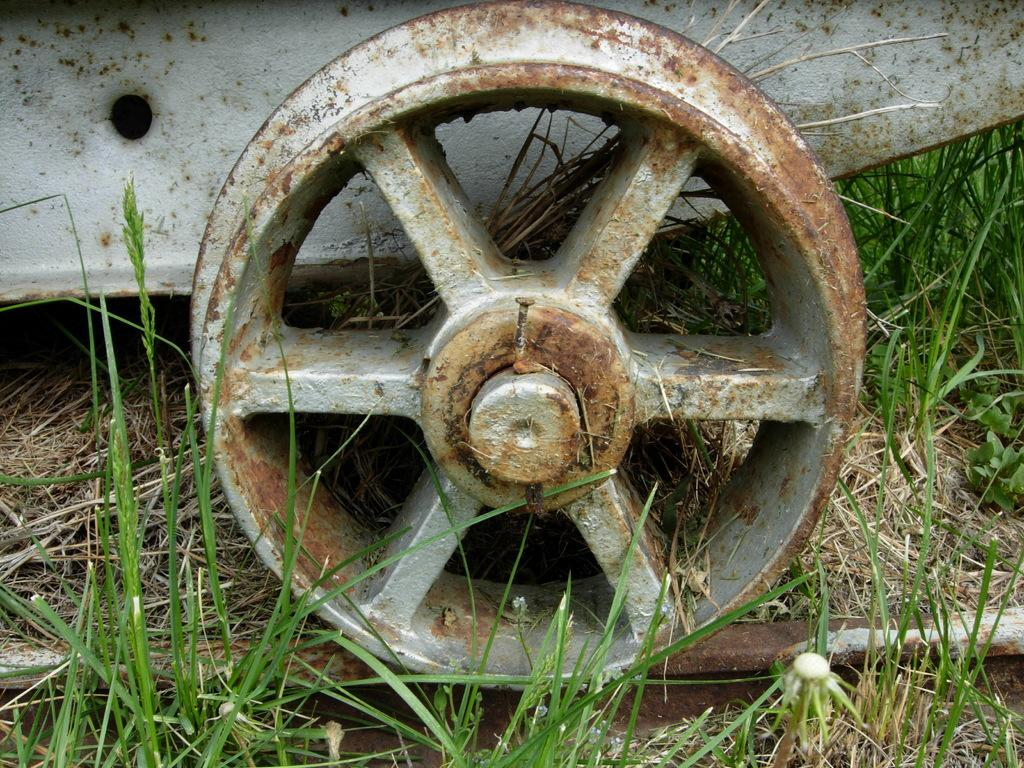What type of wheel is in the image? There is an iron wheel in the image. What is the iron wheel resting on? The iron wheel is on a track. Where is the track located? The track is on the grass. What type of boat can be seen sailing on the grass in the image? There is no boat present in the image; it features an iron wheel on a track on the grass. 